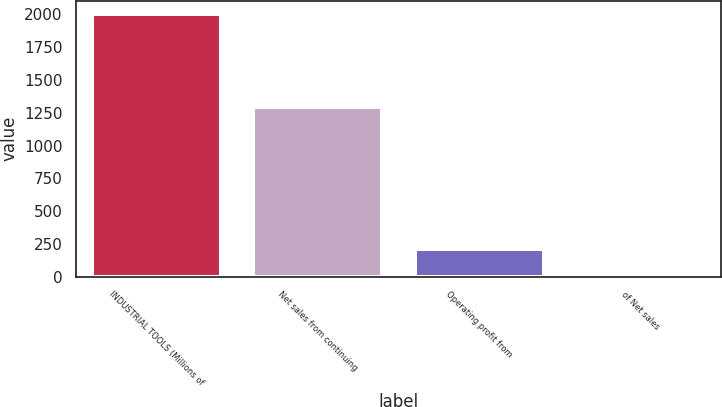Convert chart to OTSL. <chart><loc_0><loc_0><loc_500><loc_500><bar_chart><fcel>INDUSTRIAL TOOLS (Millions of<fcel>Net sales from continuing<fcel>Operating profit from<fcel>of Net sales<nl><fcel>2004<fcel>1293<fcel>209.67<fcel>10.3<nl></chart> 